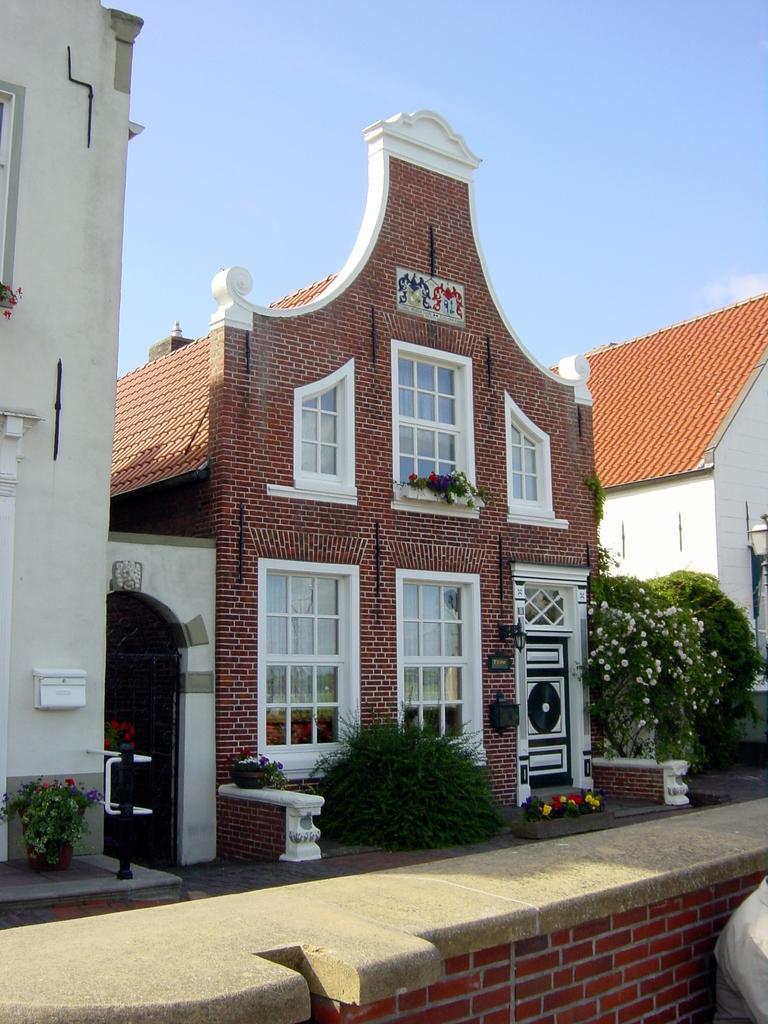Can you describe this image briefly? In the center of the image there are buildings. At the top of the image there is sky. At the bottom of the image there is wall. There are plants. 